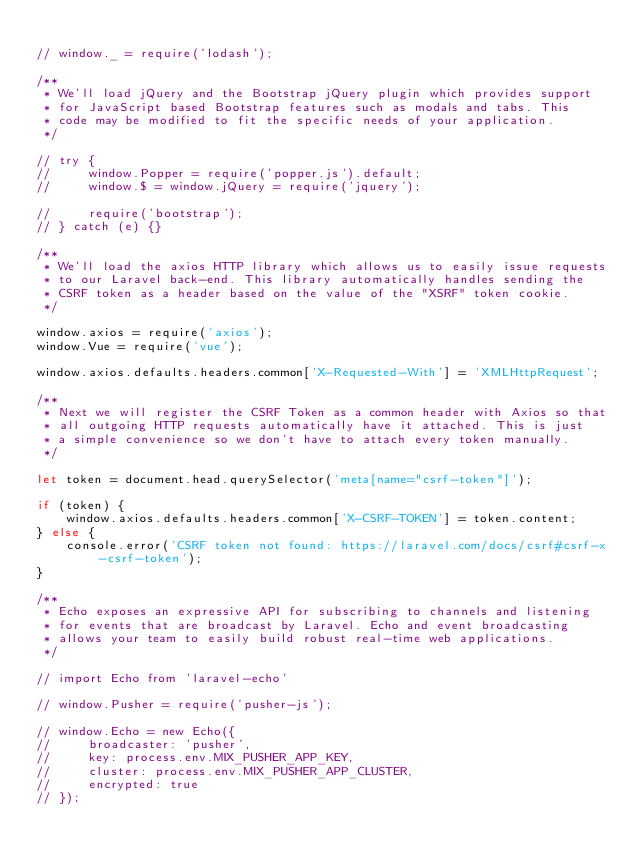Convert code to text. <code><loc_0><loc_0><loc_500><loc_500><_JavaScript_>
// window._ = require('lodash');

/**
 * We'll load jQuery and the Bootstrap jQuery plugin which provides support
 * for JavaScript based Bootstrap features such as modals and tabs. This
 * code may be modified to fit the specific needs of your application.
 */

// try {
//     window.Popper = require('popper.js').default;
//     window.$ = window.jQuery = require('jquery');

//     require('bootstrap');
// } catch (e) {}

/**
 * We'll load the axios HTTP library which allows us to easily issue requests
 * to our Laravel back-end. This library automatically handles sending the
 * CSRF token as a header based on the value of the "XSRF" token cookie.
 */

window.axios = require('axios');
window.Vue = require('vue');

window.axios.defaults.headers.common['X-Requested-With'] = 'XMLHttpRequest';

/**
 * Next we will register the CSRF Token as a common header with Axios so that
 * all outgoing HTTP requests automatically have it attached. This is just
 * a simple convenience so we don't have to attach every token manually.
 */

let token = document.head.querySelector('meta[name="csrf-token"]');

if (token) {
    window.axios.defaults.headers.common['X-CSRF-TOKEN'] = token.content;
} else {
    console.error('CSRF token not found: https://laravel.com/docs/csrf#csrf-x-csrf-token');
}

/**
 * Echo exposes an expressive API for subscribing to channels and listening
 * for events that are broadcast by Laravel. Echo and event broadcasting
 * allows your team to easily build robust real-time web applications.
 */

// import Echo from 'laravel-echo'

// window.Pusher = require('pusher-js');

// window.Echo = new Echo({
//     broadcaster: 'pusher',
//     key: process.env.MIX_PUSHER_APP_KEY,
//     cluster: process.env.MIX_PUSHER_APP_CLUSTER,
//     encrypted: true
// });
</code> 